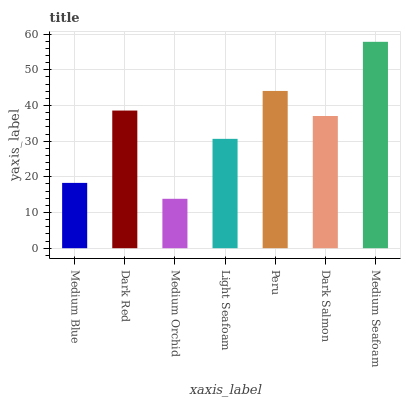Is Medium Orchid the minimum?
Answer yes or no. Yes. Is Medium Seafoam the maximum?
Answer yes or no. Yes. Is Dark Red the minimum?
Answer yes or no. No. Is Dark Red the maximum?
Answer yes or no. No. Is Dark Red greater than Medium Blue?
Answer yes or no. Yes. Is Medium Blue less than Dark Red?
Answer yes or no. Yes. Is Medium Blue greater than Dark Red?
Answer yes or no. No. Is Dark Red less than Medium Blue?
Answer yes or no. No. Is Dark Salmon the high median?
Answer yes or no. Yes. Is Dark Salmon the low median?
Answer yes or no. Yes. Is Medium Seafoam the high median?
Answer yes or no. No. Is Medium Blue the low median?
Answer yes or no. No. 